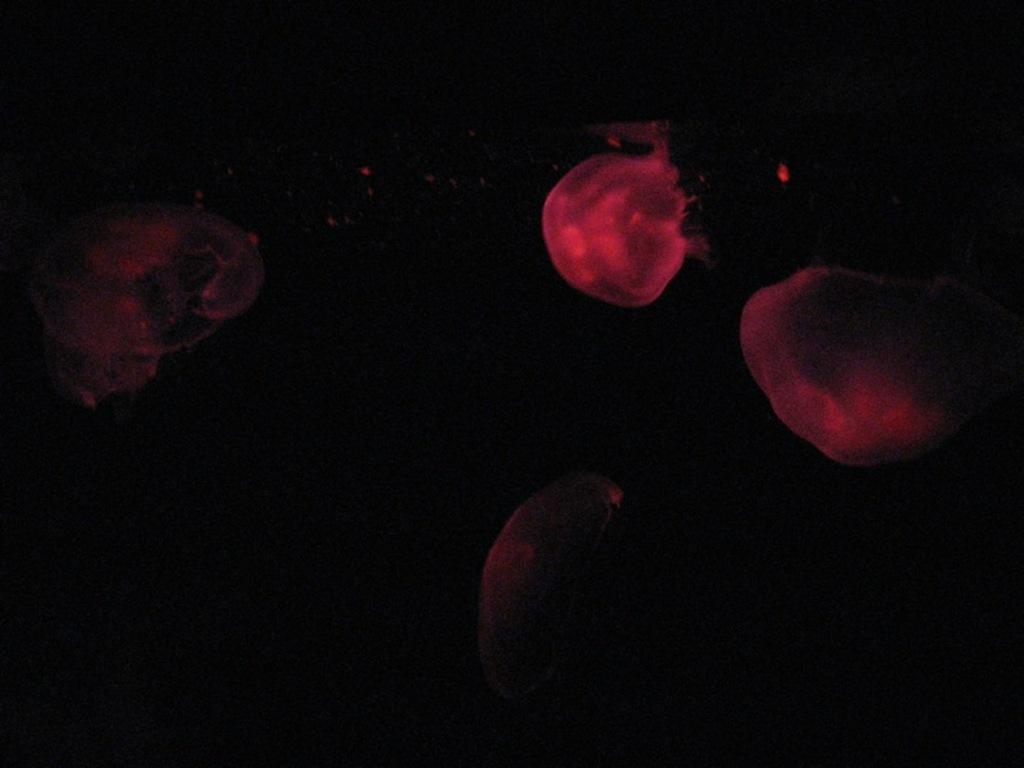What is depicted in the image? There are jellyfishes or blood cells in the image. What color are they? They are in red color. What is the color of the background in the image? The background of the image is black. How is the background of the image? The background is blurred. What type of sweater is being worn by the jellyfish in the image? There are no people or clothing items present in the image, as it features jellyfishes or blood cells in a black and blurred background. 